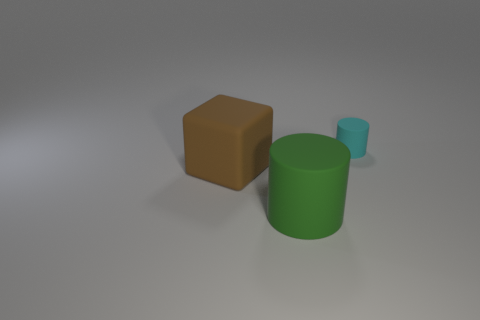The big thing that is behind the large green matte thing is what color?
Keep it short and to the point. Brown. Are there any other brown rubber objects that have the same size as the brown object?
Keep it short and to the point. No. There is a brown cube that is the same size as the green rubber cylinder; what is it made of?
Provide a succinct answer. Rubber. How many things are rubber objects that are behind the green thing or rubber things that are in front of the large brown object?
Make the answer very short. 3. Are there any cyan objects of the same shape as the brown object?
Give a very brief answer. No. What number of matte objects are small purple objects or big brown things?
Provide a short and direct response. 1. The brown thing is what shape?
Keep it short and to the point. Cube. What number of objects are the same material as the block?
Give a very brief answer. 2. There is a large block that is made of the same material as the small cyan thing; what color is it?
Offer a very short reply. Brown. Does the cylinder behind the green rubber cylinder have the same size as the large green object?
Provide a succinct answer. No. 